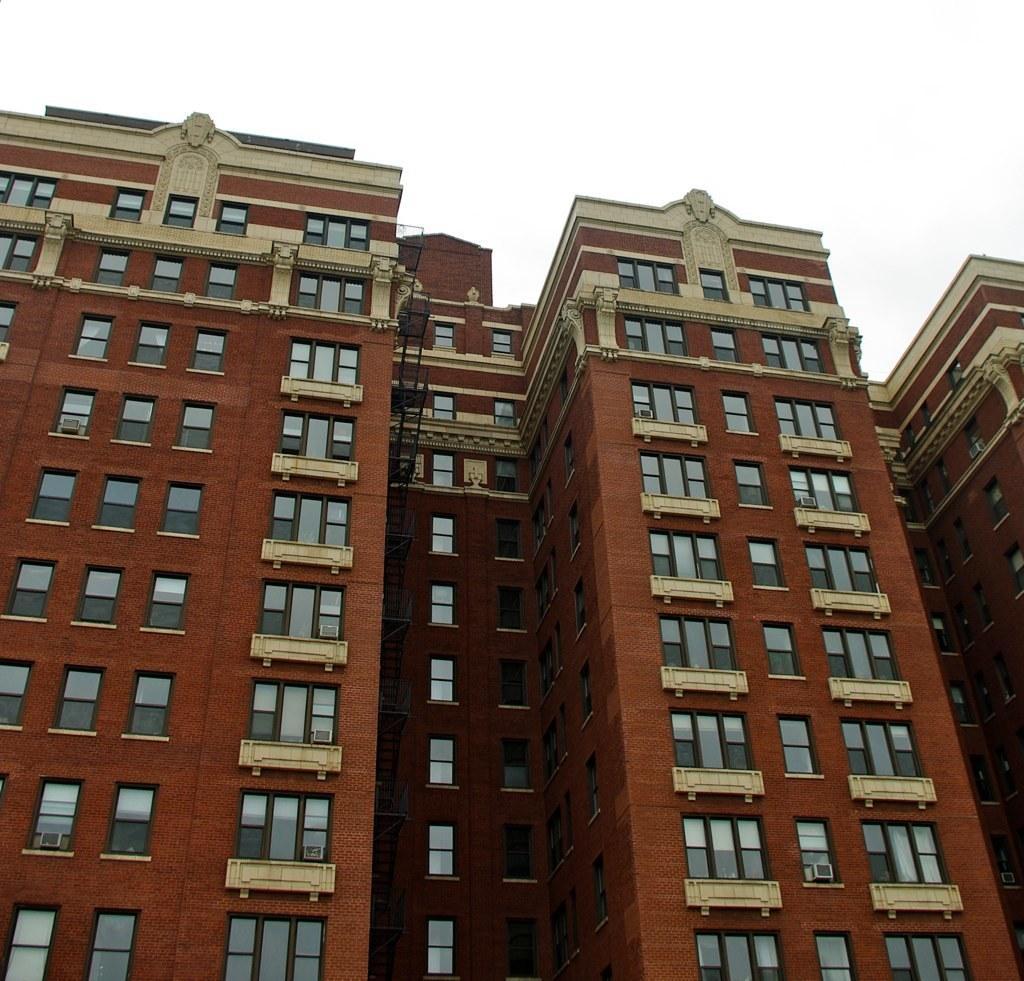Could you give a brief overview of what you see in this image? In the center of the image there are buildings. At the top there is sky. 